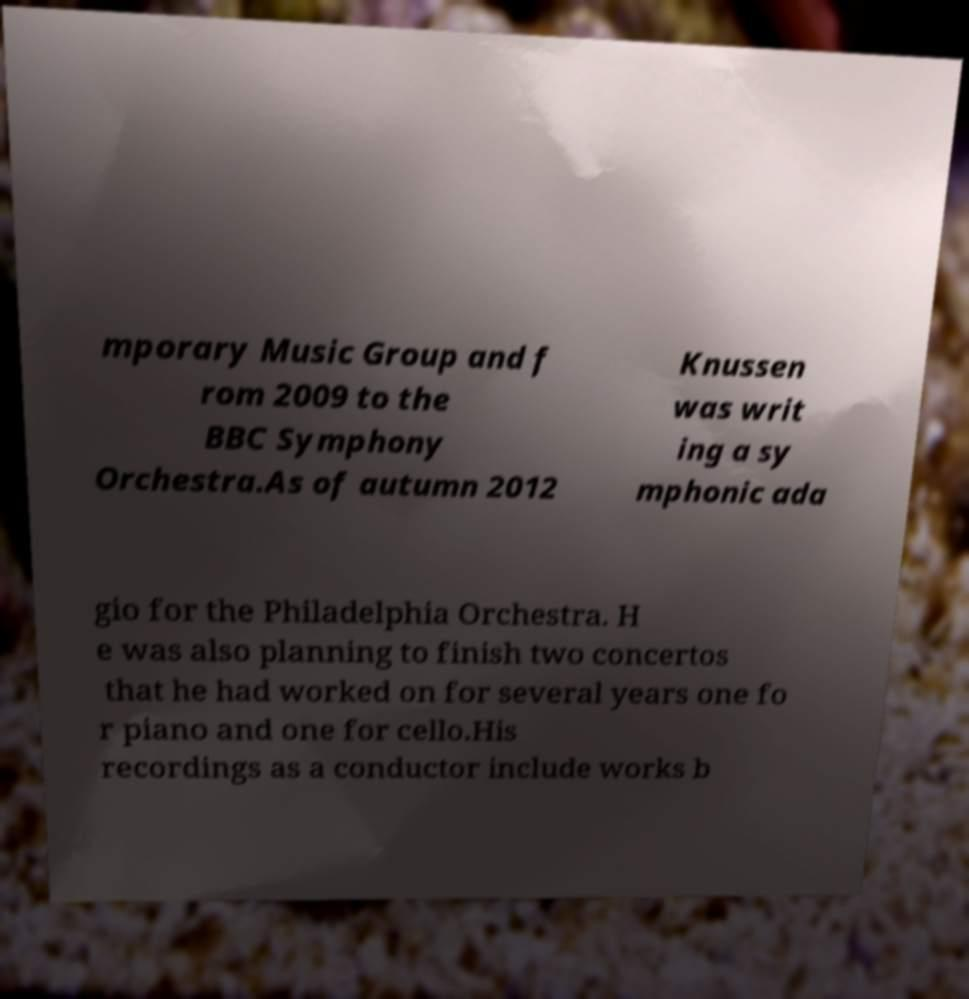Could you assist in decoding the text presented in this image and type it out clearly? mporary Music Group and f rom 2009 to the BBC Symphony Orchestra.As of autumn 2012 Knussen was writ ing a sy mphonic ada gio for the Philadelphia Orchestra. H e was also planning to finish two concertos that he had worked on for several years one fo r piano and one for cello.His recordings as a conductor include works b 